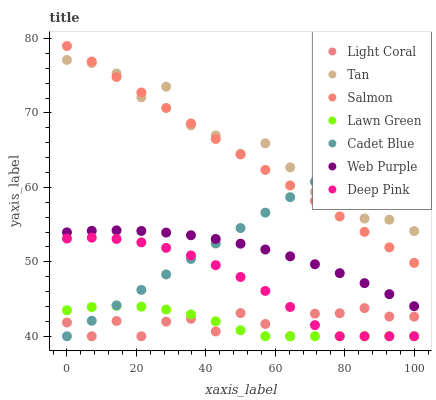Does Lawn Green have the minimum area under the curve?
Answer yes or no. Yes. Does Tan have the maximum area under the curve?
Answer yes or no. Yes. Does Cadet Blue have the minimum area under the curve?
Answer yes or no. No. Does Cadet Blue have the maximum area under the curve?
Answer yes or no. No. Is Cadet Blue the smoothest?
Answer yes or no. Yes. Is Tan the roughest?
Answer yes or no. Yes. Is Salmon the smoothest?
Answer yes or no. No. Is Salmon the roughest?
Answer yes or no. No. Does Lawn Green have the lowest value?
Answer yes or no. Yes. Does Salmon have the lowest value?
Answer yes or no. No. Does Salmon have the highest value?
Answer yes or no. Yes. Does Cadet Blue have the highest value?
Answer yes or no. No. Is Light Coral less than Web Purple?
Answer yes or no. Yes. Is Web Purple greater than Deep Pink?
Answer yes or no. Yes. Does Lawn Green intersect Light Coral?
Answer yes or no. Yes. Is Lawn Green less than Light Coral?
Answer yes or no. No. Is Lawn Green greater than Light Coral?
Answer yes or no. No. Does Light Coral intersect Web Purple?
Answer yes or no. No. 